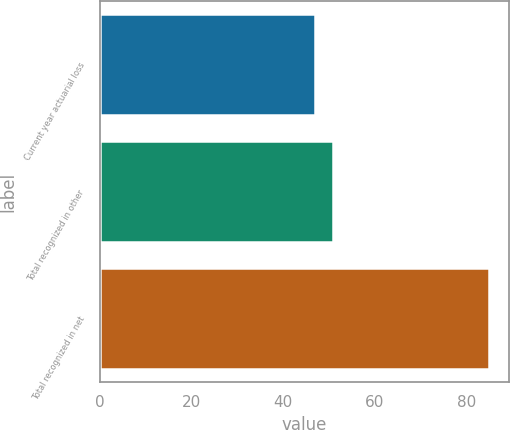Convert chart to OTSL. <chart><loc_0><loc_0><loc_500><loc_500><bar_chart><fcel>Current year actuarial loss<fcel>Total recognized in other<fcel>Total recognized in net<nl><fcel>47<fcel>50.8<fcel>85<nl></chart> 